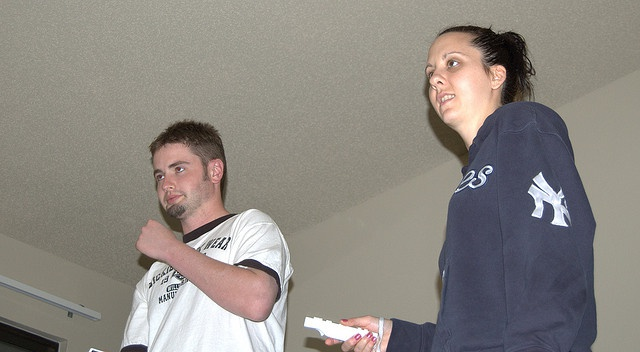Describe the objects in this image and their specific colors. I can see people in darkgray, gray, tan, and black tones, people in darkgray, white, lightpink, and gray tones, and remote in darkgray and white tones in this image. 